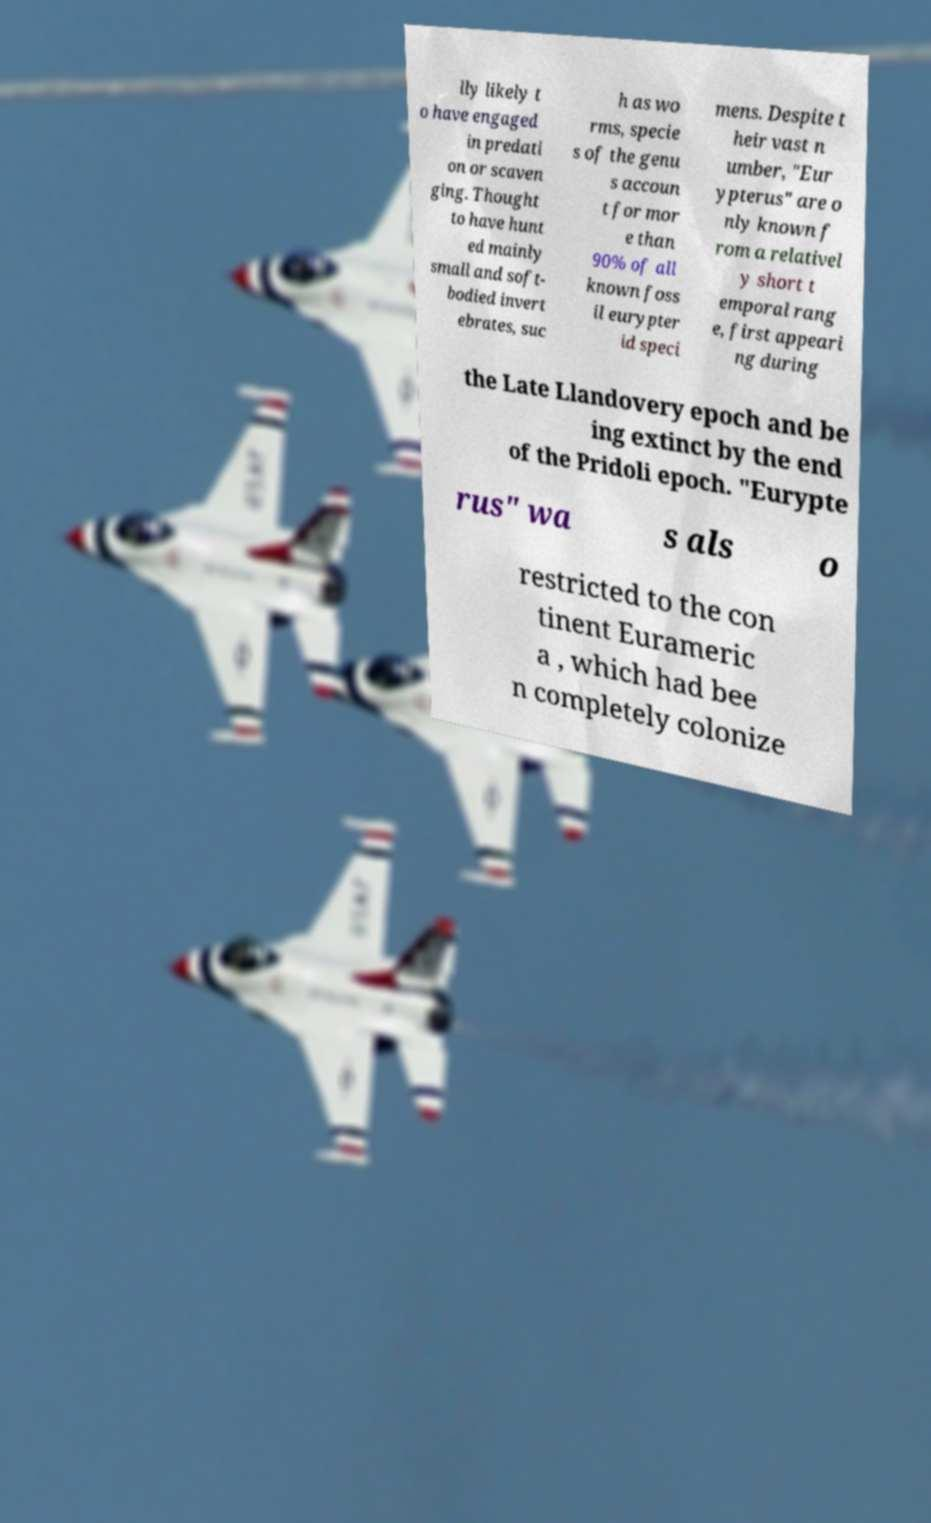Please read and relay the text visible in this image. What does it say? lly likely t o have engaged in predati on or scaven ging. Thought to have hunt ed mainly small and soft- bodied invert ebrates, suc h as wo rms, specie s of the genu s accoun t for mor e than 90% of all known foss il eurypter id speci mens. Despite t heir vast n umber, "Eur ypterus" are o nly known f rom a relativel y short t emporal rang e, first appeari ng during the Late Llandovery epoch and be ing extinct by the end of the Pridoli epoch. "Eurypte rus" wa s als o restricted to the con tinent Eurameric a , which had bee n completely colonize 